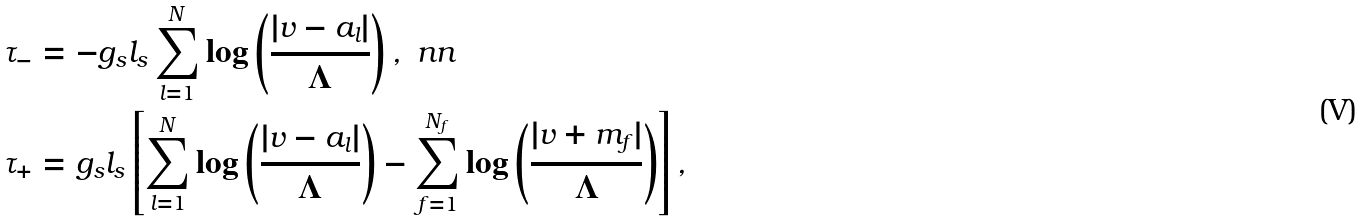Convert formula to latex. <formula><loc_0><loc_0><loc_500><loc_500>\tau _ { - } & = - g _ { s } l _ { s } \sum _ { l = 1 } ^ { N } \log \left ( \frac { | v - a _ { l } | } { \Lambda } \right ) , \ n n \\ \tau _ { + } & = g _ { s } l _ { s } \left [ \sum _ { l = 1 } ^ { N } \log \left ( \frac { | v - a _ { l } | } { \Lambda } \right ) - \sum _ { f = 1 } ^ { N _ { f } } \log \left ( \frac { | v + m _ { f } | } { \Lambda } \right ) \right ] ,</formula> 